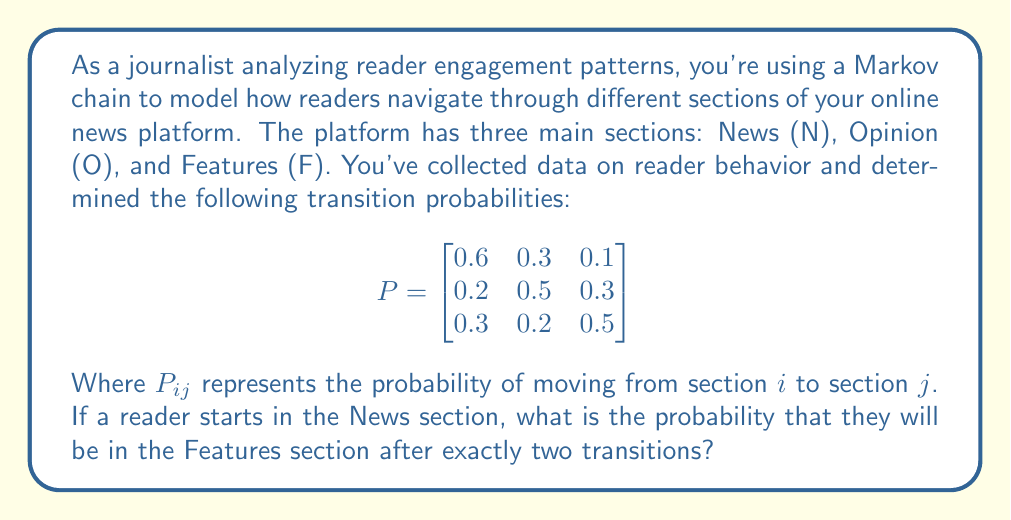Provide a solution to this math problem. To solve this problem, we need to use the Chapman-Kolmogorov equations and matrix multiplication. We'll follow these steps:

1) The initial state vector is $\mathbf{v_0} = [1, 0, 0]$ since the reader starts in the News section.

2) We need to calculate $P^2$ (the transition matrix squared) to find the probabilities after two transitions:

   $$P^2 = P \times P = \begin{bmatrix}
   0.6 & 0.3 & 0.1 \\
   0.2 & 0.5 & 0.3 \\
   0.3 & 0.2 & 0.5
   \end{bmatrix} \times \begin{bmatrix}
   0.6 & 0.3 & 0.1 \\
   0.2 & 0.5 & 0.3 \\
   0.3 & 0.2 & 0.5
   \end{bmatrix}$$

3) Performing the matrix multiplication:

   $$P^2 = \begin{bmatrix}
   0.42 & 0.33 & 0.25 \\
   0.33 & 0.38 & 0.29 \\
   0.39 & 0.31 & 0.30
   \end{bmatrix}$$

4) The probability of being in the Features section (F) after two transitions, starting from News (N), is the element in the first row, third column of $P^2$:

   $P_{NF}^{(2)} = 0.25$

Therefore, the probability of a reader being in the Features section after exactly two transitions, starting from the News section, is 0.25 or 25%.
Answer: 0.25 